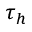Convert formula to latex. <formula><loc_0><loc_0><loc_500><loc_500>\tau _ { h }</formula> 